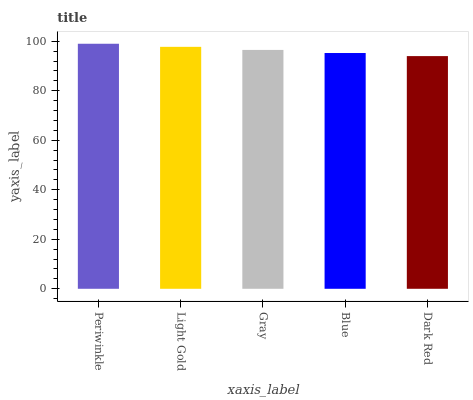Is Dark Red the minimum?
Answer yes or no. Yes. Is Periwinkle the maximum?
Answer yes or no. Yes. Is Light Gold the minimum?
Answer yes or no. No. Is Light Gold the maximum?
Answer yes or no. No. Is Periwinkle greater than Light Gold?
Answer yes or no. Yes. Is Light Gold less than Periwinkle?
Answer yes or no. Yes. Is Light Gold greater than Periwinkle?
Answer yes or no. No. Is Periwinkle less than Light Gold?
Answer yes or no. No. Is Gray the high median?
Answer yes or no. Yes. Is Gray the low median?
Answer yes or no. Yes. Is Light Gold the high median?
Answer yes or no. No. Is Periwinkle the low median?
Answer yes or no. No. 